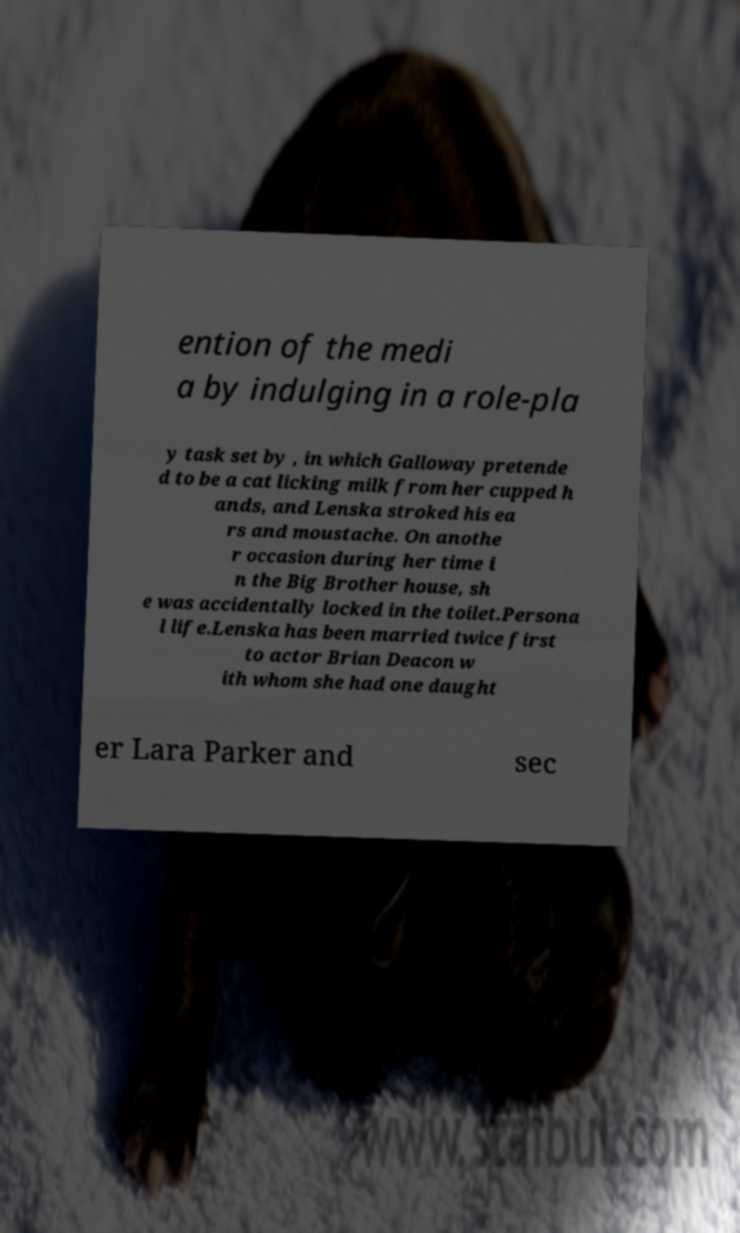For documentation purposes, I need the text within this image transcribed. Could you provide that? ention of the medi a by indulging in a role-pla y task set by , in which Galloway pretende d to be a cat licking milk from her cupped h ands, and Lenska stroked his ea rs and moustache. On anothe r occasion during her time i n the Big Brother house, sh e was accidentally locked in the toilet.Persona l life.Lenska has been married twice first to actor Brian Deacon w ith whom she had one daught er Lara Parker and sec 